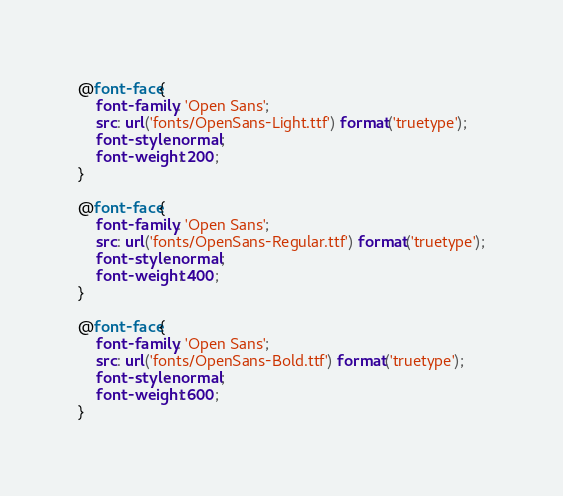Convert code to text. <code><loc_0><loc_0><loc_500><loc_500><_CSS_>@font-face{
	font-family : 'Open Sans';
	src: url('fonts/OpenSans-Light.ttf') format('truetype');
	font-style: normal;
	font-weight: 200;
}

@font-face{
	font-family : 'Open Sans';
	src: url('fonts/OpenSans-Regular.ttf') format('truetype');
	font-style: normal;
	font-weight: 400;
}

@font-face{
	font-family : 'Open Sans';
	src: url('fonts/OpenSans-Bold.ttf') format('truetype');
	font-style: normal;
	font-weight: 600;
}</code> 